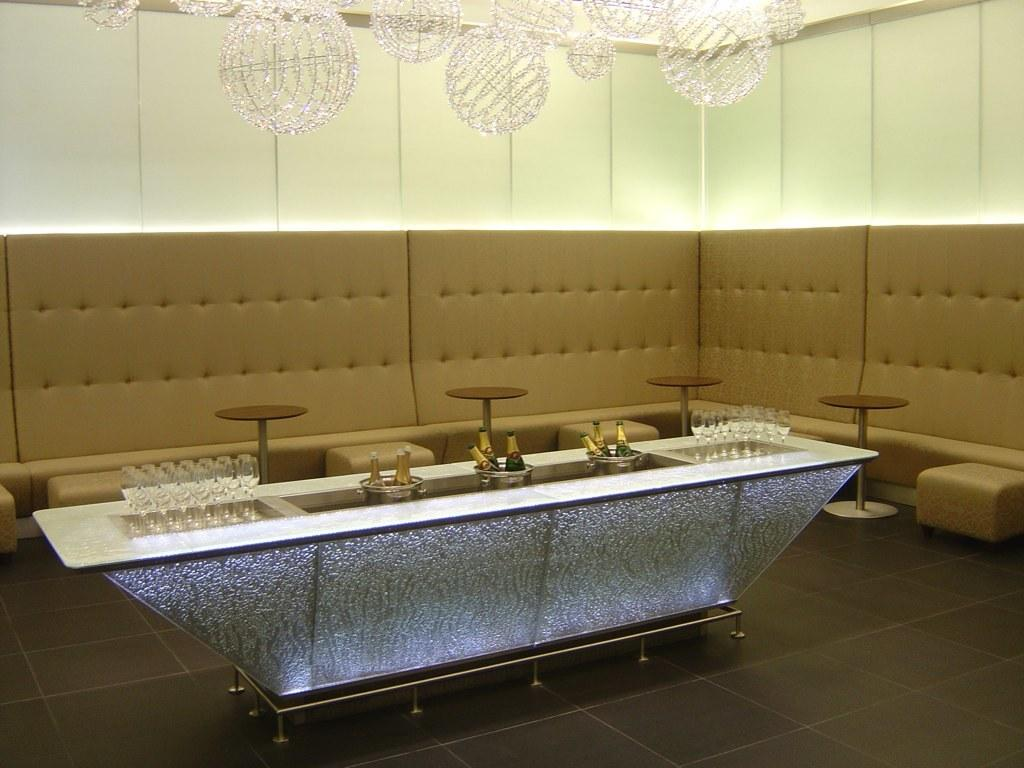What type of furniture is in the image? There is a brown sofa in the image. What other piece of furniture is present in the image? There is a table in the image. What items can be seen on the table? There are glasses and wine bottles on the table. What type of lighting is present in the image? There are lights hanging at the top of the image. How many friends are riding bikes in the image? There are no bikes or friends present in the image. What type of joke is being told by the person sitting on the sofa? There is no person or joke present in the image; it only features a brown sofa, a table, glasses, wine bottles, and hanging lights. 